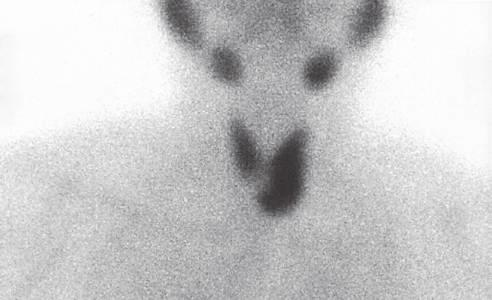what is preoperative scintigraphy useful for?
Answer the question using a single word or phrase. Localizing and distinguishing adenomas from parathyroid hyperplasia 